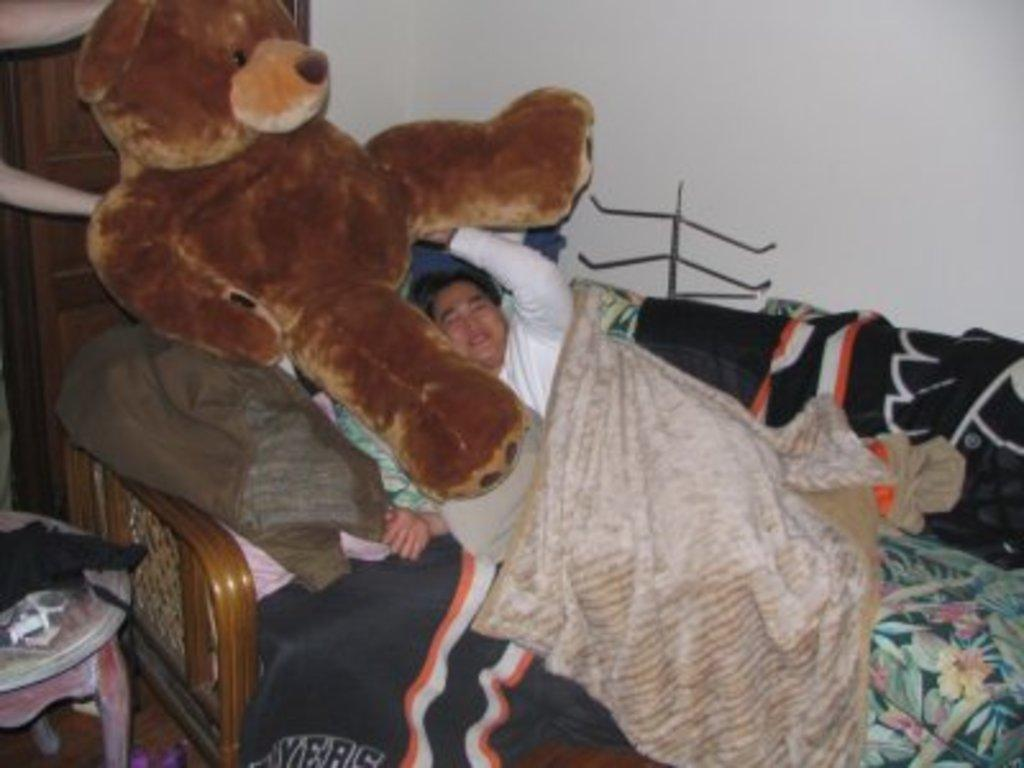What is the person in the image doing? The person is sleeping on the bed. What is covering the person in the image? The person is wearing a blanket. What object is beside the person in the image? There is a teddy bear beside the person. What furniture can be seen on the left side of the image? There is a table and a cupboard on the left side of the image. What is on the table in the image? The table has clothes on it. What type of seed can be seen growing on the person's finger in the image? There is no seed or finger present in the image; the person is sleeping with a blanket and a teddy bear beside them. 